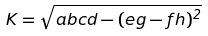<formula> <loc_0><loc_0><loc_500><loc_500>K = \sqrt { a b c d - ( e g - f h ) ^ { 2 } }</formula> 